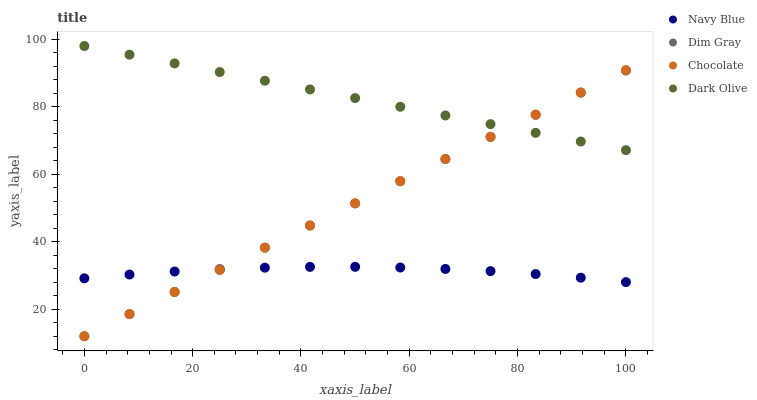Does Navy Blue have the minimum area under the curve?
Answer yes or no. Yes. Does Dark Olive have the maximum area under the curve?
Answer yes or no. Yes. Does Dim Gray have the minimum area under the curve?
Answer yes or no. No. Does Dim Gray have the maximum area under the curve?
Answer yes or no. No. Is Dim Gray the smoothest?
Answer yes or no. Yes. Is Navy Blue the roughest?
Answer yes or no. Yes. Is Navy Blue the smoothest?
Answer yes or no. No. Is Dim Gray the roughest?
Answer yes or no. No. Does Dim Gray have the lowest value?
Answer yes or no. Yes. Does Navy Blue have the lowest value?
Answer yes or no. No. Does Dark Olive have the highest value?
Answer yes or no. Yes. Does Dim Gray have the highest value?
Answer yes or no. No. Is Navy Blue less than Dark Olive?
Answer yes or no. Yes. Is Dark Olive greater than Navy Blue?
Answer yes or no. Yes. Does Chocolate intersect Dim Gray?
Answer yes or no. Yes. Is Chocolate less than Dim Gray?
Answer yes or no. No. Is Chocolate greater than Dim Gray?
Answer yes or no. No. Does Navy Blue intersect Dark Olive?
Answer yes or no. No. 